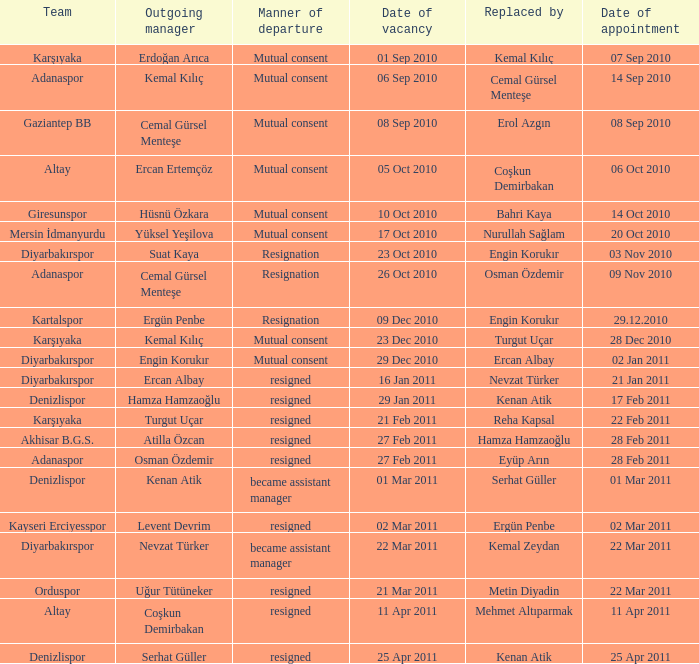Who succeeded the manager of akhisar b.g.s.? Hamza Hamzaoğlu. 